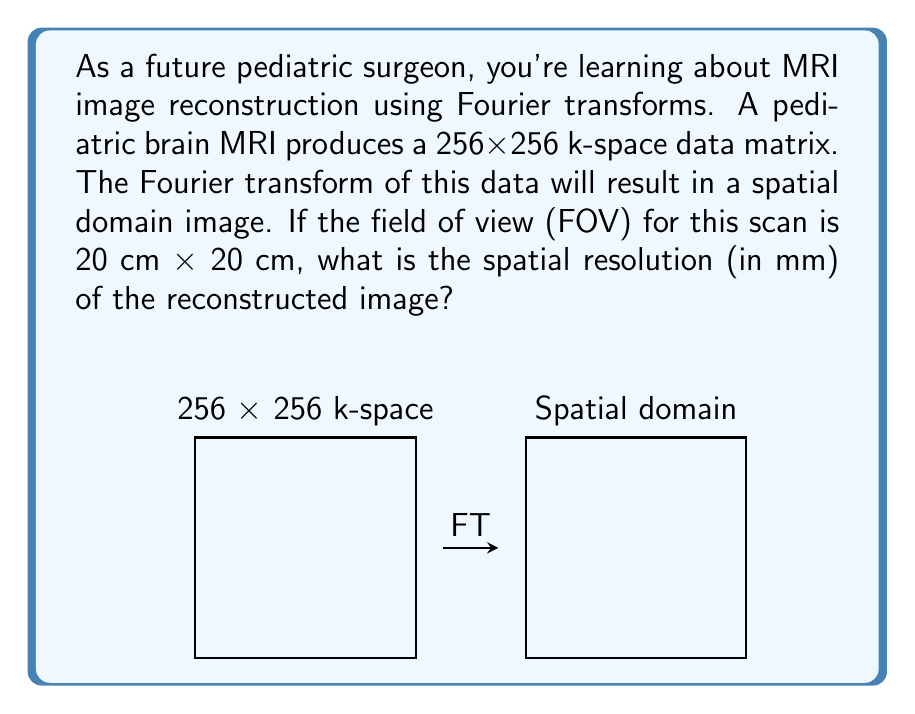Teach me how to tackle this problem. Let's approach this step-by-step:

1) The k-space data matrix size is 256x256.

2) The Fourier transform will convert this to a spatial domain image of the same size: 256x256 pixels.

3) The field of view (FOV) is 20 cm x 20 cm, which is equivalent to 200 mm x 200 mm.

4) To find the spatial resolution, we need to determine the size of each pixel in mm.

5) The spatial resolution is calculated by dividing the FOV by the number of pixels in each dimension:

   $$ \text{Resolution} = \frac{\text{FOV}}{\text{Number of pixels}} $$

6) For both x and y dimensions:

   $$ \text{Resolution}_x = \text{Resolution}_y = \frac{200 \text{ mm}}{256} $$

7) Calculating:

   $$ \text{Resolution} = \frac{200}{256} = 0.78125 \text{ mm} $$

Therefore, the spatial resolution of the reconstructed image is approximately 0.78 mm.
Answer: 0.78 mm 